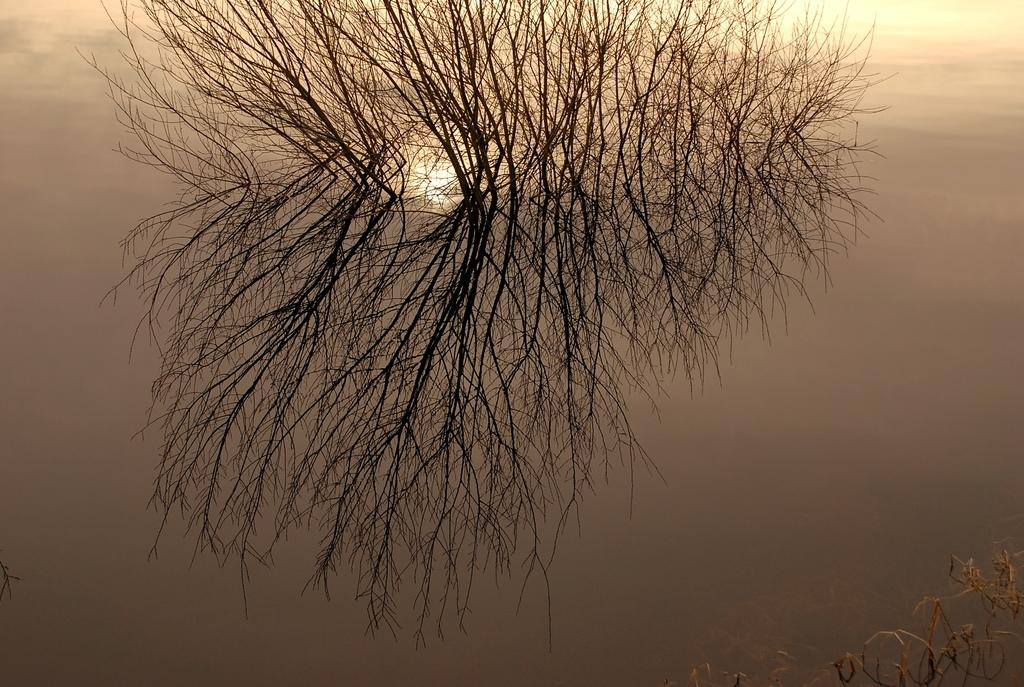What type of vegetation can be seen in the image? There are branches of a dry tree in the image. What can be observed through the branches in the image? Sunlight is visible through the branches in the image. What type of bird is perched on the banana in the image? There is no bird or banana present in the image; it only features branches of a dry tree and sunlight. 